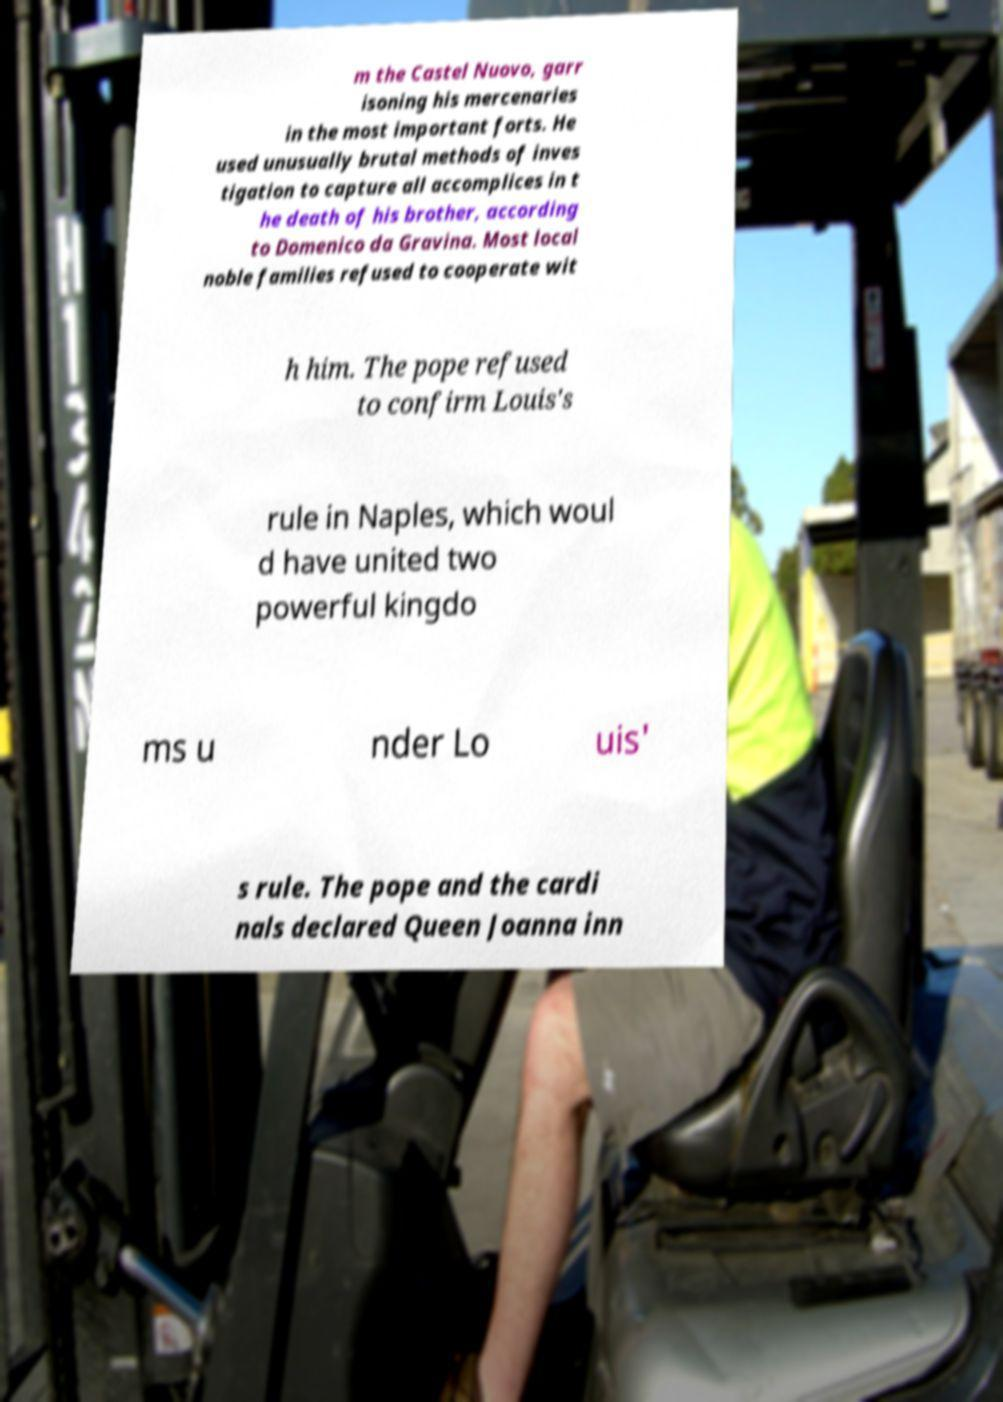What messages or text are displayed in this image? I need them in a readable, typed format. m the Castel Nuovo, garr isoning his mercenaries in the most important forts. He used unusually brutal methods of inves tigation to capture all accomplices in t he death of his brother, according to Domenico da Gravina. Most local noble families refused to cooperate wit h him. The pope refused to confirm Louis's rule in Naples, which woul d have united two powerful kingdo ms u nder Lo uis' s rule. The pope and the cardi nals declared Queen Joanna inn 